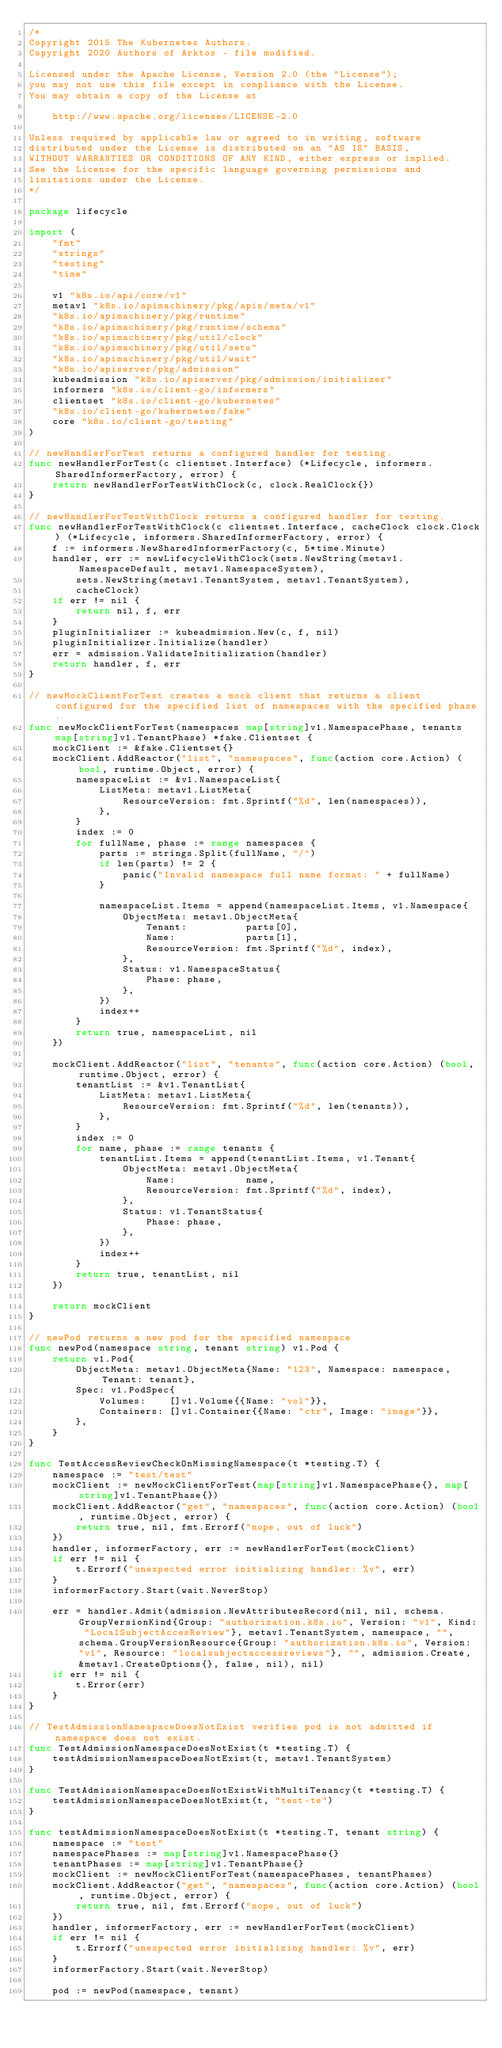<code> <loc_0><loc_0><loc_500><loc_500><_Go_>/*
Copyright 2015 The Kubernetes Authors.
Copyright 2020 Authors of Arktos - file modified.

Licensed under the Apache License, Version 2.0 (the "License");
you may not use this file except in compliance with the License.
You may obtain a copy of the License at

    http://www.apache.org/licenses/LICENSE-2.0

Unless required by applicable law or agreed to in writing, software
distributed under the License is distributed on an "AS IS" BASIS,
WITHOUT WARRANTIES OR CONDITIONS OF ANY KIND, either express or implied.
See the License for the specific language governing permissions and
limitations under the License.
*/

package lifecycle

import (
	"fmt"
	"strings"
	"testing"
	"time"

	v1 "k8s.io/api/core/v1"
	metav1 "k8s.io/apimachinery/pkg/apis/meta/v1"
	"k8s.io/apimachinery/pkg/runtime"
	"k8s.io/apimachinery/pkg/runtime/schema"
	"k8s.io/apimachinery/pkg/util/clock"
	"k8s.io/apimachinery/pkg/util/sets"
	"k8s.io/apimachinery/pkg/util/wait"
	"k8s.io/apiserver/pkg/admission"
	kubeadmission "k8s.io/apiserver/pkg/admission/initializer"
	informers "k8s.io/client-go/informers"
	clientset "k8s.io/client-go/kubernetes"
	"k8s.io/client-go/kubernetes/fake"
	core "k8s.io/client-go/testing"
)

// newHandlerForTest returns a configured handler for testing.
func newHandlerForTest(c clientset.Interface) (*Lifecycle, informers.SharedInformerFactory, error) {
	return newHandlerForTestWithClock(c, clock.RealClock{})
}

// newHandlerForTestWithClock returns a configured handler for testing.
func newHandlerForTestWithClock(c clientset.Interface, cacheClock clock.Clock) (*Lifecycle, informers.SharedInformerFactory, error) {
	f := informers.NewSharedInformerFactory(c, 5*time.Minute)
	handler, err := newLifecycleWithClock(sets.NewString(metav1.NamespaceDefault, metav1.NamespaceSystem),
		sets.NewString(metav1.TenantSystem, metav1.TenantSystem),
		cacheClock)
	if err != nil {
		return nil, f, err
	}
	pluginInitializer := kubeadmission.New(c, f, nil)
	pluginInitializer.Initialize(handler)
	err = admission.ValidateInitialization(handler)
	return handler, f, err
}

// newMockClientForTest creates a mock client that returns a client configured for the specified list of namespaces with the specified phase.
func newMockClientForTest(namespaces map[string]v1.NamespacePhase, tenants map[string]v1.TenantPhase) *fake.Clientset {
	mockClient := &fake.Clientset{}
	mockClient.AddReactor("list", "namespaces", func(action core.Action) (bool, runtime.Object, error) {
		namespaceList := &v1.NamespaceList{
			ListMeta: metav1.ListMeta{
				ResourceVersion: fmt.Sprintf("%d", len(namespaces)),
			},
		}
		index := 0
		for fullName, phase := range namespaces {
			parts := strings.Split(fullName, "/")
			if len(parts) != 2 {
				panic("Invalid namespace full name format: " + fullName)
			}

			namespaceList.Items = append(namespaceList.Items, v1.Namespace{
				ObjectMeta: metav1.ObjectMeta{
					Tenant:          parts[0],
					Name:            parts[1],
					ResourceVersion: fmt.Sprintf("%d", index),
				},
				Status: v1.NamespaceStatus{
					Phase: phase,
				},
			})
			index++
		}
		return true, namespaceList, nil
	})

	mockClient.AddReactor("list", "tenants", func(action core.Action) (bool, runtime.Object, error) {
		tenantList := &v1.TenantList{
			ListMeta: metav1.ListMeta{
				ResourceVersion: fmt.Sprintf("%d", len(tenants)),
			},
		}
		index := 0
		for name, phase := range tenants {
			tenantList.Items = append(tenantList.Items, v1.Tenant{
				ObjectMeta: metav1.ObjectMeta{
					Name:            name,
					ResourceVersion: fmt.Sprintf("%d", index),
				},
				Status: v1.TenantStatus{
					Phase: phase,
				},
			})
			index++
		}
		return true, tenantList, nil
	})

	return mockClient
}

// newPod returns a new pod for the specified namespace
func newPod(namespace string, tenant string) v1.Pod {
	return v1.Pod{
		ObjectMeta: metav1.ObjectMeta{Name: "123", Namespace: namespace, Tenant: tenant},
		Spec: v1.PodSpec{
			Volumes:    []v1.Volume{{Name: "vol"}},
			Containers: []v1.Container{{Name: "ctr", Image: "image"}},
		},
	}
}

func TestAccessReviewCheckOnMissingNamespace(t *testing.T) {
	namespace := "test/test"
	mockClient := newMockClientForTest(map[string]v1.NamespacePhase{}, map[string]v1.TenantPhase{})
	mockClient.AddReactor("get", "namespaces", func(action core.Action) (bool, runtime.Object, error) {
		return true, nil, fmt.Errorf("nope, out of luck")
	})
	handler, informerFactory, err := newHandlerForTest(mockClient)
	if err != nil {
		t.Errorf("unexpected error initializing handler: %v", err)
	}
	informerFactory.Start(wait.NeverStop)

	err = handler.Admit(admission.NewAttributesRecord(nil, nil, schema.GroupVersionKind{Group: "authorization.k8s.io", Version: "v1", Kind: "LocalSubjectAccesReview"}, metav1.TenantSystem, namespace, "", schema.GroupVersionResource{Group: "authorization.k8s.io", Version: "v1", Resource: "localsubjectaccessreviews"}, "", admission.Create, &metav1.CreateOptions{}, false, nil), nil)
	if err != nil {
		t.Error(err)
	}
}

// TestAdmissionNamespaceDoesNotExist verifies pod is not admitted if namespace does not exist.
func TestAdmissionNamespaceDoesNotExist(t *testing.T) {
	testAdmissionNamespaceDoesNotExist(t, metav1.TenantSystem)
}

func TestAdmissionNamespaceDoesNotExistWithMultiTenancy(t *testing.T) {
	testAdmissionNamespaceDoesNotExist(t, "test-te")
}

func testAdmissionNamespaceDoesNotExist(t *testing.T, tenant string) {
	namespace := "test"
	namespacePhases := map[string]v1.NamespacePhase{}
	tenantPhases := map[string]v1.TenantPhase{}
	mockClient := newMockClientForTest(namespacePhases, tenantPhases)
	mockClient.AddReactor("get", "namespaces", func(action core.Action) (bool, runtime.Object, error) {
		return true, nil, fmt.Errorf("nope, out of luck")
	})
	handler, informerFactory, err := newHandlerForTest(mockClient)
	if err != nil {
		t.Errorf("unexpected error initializing handler: %v", err)
	}
	informerFactory.Start(wait.NeverStop)

	pod := newPod(namespace, tenant)</code> 